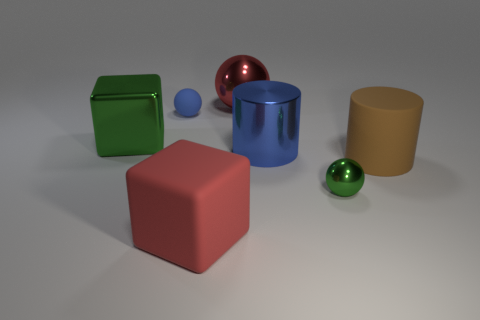There is a large cylinder that is right of the shiny ball right of the large metal sphere; are there any big brown things that are on the right side of it?
Your answer should be compact. No. What shape is the red rubber object that is the same size as the blue metal cylinder?
Provide a succinct answer. Cube. What color is the other big object that is the same shape as the big blue object?
Your response must be concise. Brown. What number of things are either tiny blue spheres or blue shiny objects?
Offer a terse response. 2. Is the shape of the green object that is to the left of the tiny green shiny thing the same as the blue object right of the big red ball?
Your answer should be very brief. No. There is a big metal object that is to the left of the large matte cube; what shape is it?
Ensure brevity in your answer.  Cube. Are there an equal number of big metal blocks to the right of the blue matte ball and tiny matte balls that are behind the big rubber cube?
Offer a very short reply. No. What number of objects are small yellow metallic cylinders or red things in front of the large blue thing?
Ensure brevity in your answer.  1. The metal object that is both left of the tiny green metal object and right of the red sphere has what shape?
Provide a short and direct response. Cylinder. What is the material of the big red thing that is behind the green shiny object in front of the big green metal thing?
Keep it short and to the point. Metal. 